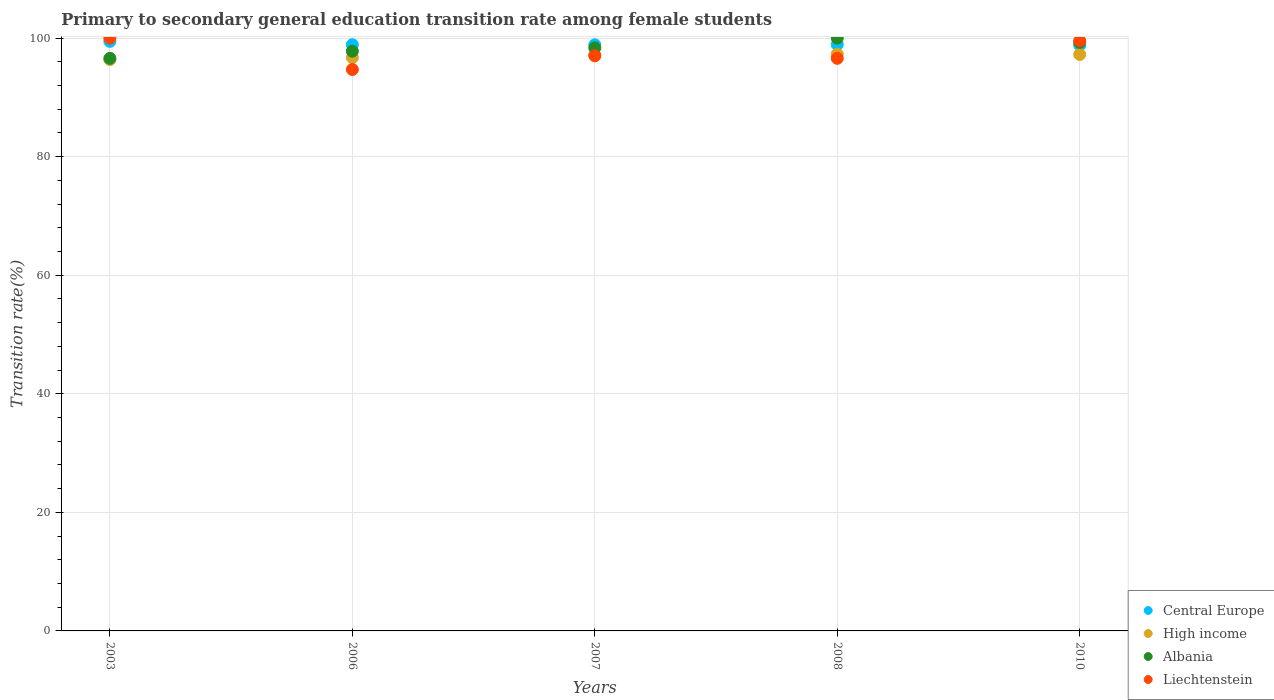Across all years, what is the maximum transition rate in Central Europe?
Your response must be concise. 99.45. Across all years, what is the minimum transition rate in High income?
Provide a succinct answer. 96.4. What is the total transition rate in Central Europe in the graph?
Offer a very short reply. 494.95. What is the difference between the transition rate in Liechtenstein in 2008 and that in 2010?
Give a very brief answer. -2.96. What is the difference between the transition rate in Albania in 2008 and the transition rate in Central Europe in 2007?
Offer a very short reply. 1.12. What is the average transition rate in High income per year?
Provide a succinct answer. 96.97. In the year 2007, what is the difference between the transition rate in Albania and transition rate in High income?
Offer a terse response. 1.19. In how many years, is the transition rate in Liechtenstein greater than 60 %?
Your response must be concise. 5. What is the ratio of the transition rate in Albania in 2006 to that in 2008?
Give a very brief answer. 0.98. Is the transition rate in Central Europe in 2007 less than that in 2008?
Provide a succinct answer. Yes. Is the difference between the transition rate in Albania in 2006 and 2007 greater than the difference between the transition rate in High income in 2006 and 2007?
Your answer should be compact. No. What is the difference between the highest and the second highest transition rate in Central Europe?
Keep it short and to the point. 0.53. What is the difference between the highest and the lowest transition rate in Central Europe?
Offer a terse response. 0.65. Is it the case that in every year, the sum of the transition rate in Central Europe and transition rate in Liechtenstein  is greater than the sum of transition rate in Albania and transition rate in High income?
Keep it short and to the point. No. Is it the case that in every year, the sum of the transition rate in Albania and transition rate in Liechtenstein  is greater than the transition rate in High income?
Your response must be concise. Yes. Does the transition rate in Central Europe monotonically increase over the years?
Offer a terse response. No. Is the transition rate in Liechtenstein strictly less than the transition rate in High income over the years?
Your answer should be very brief. No. What is the title of the graph?
Your answer should be very brief. Primary to secondary general education transition rate among female students. Does "Somalia" appear as one of the legend labels in the graph?
Your response must be concise. No. What is the label or title of the Y-axis?
Provide a succinct answer. Transition rate(%). What is the Transition rate(%) of Central Europe in 2003?
Give a very brief answer. 99.45. What is the Transition rate(%) of High income in 2003?
Your answer should be very brief. 96.4. What is the Transition rate(%) of Albania in 2003?
Your answer should be compact. 96.59. What is the Transition rate(%) in Central Europe in 2006?
Provide a short and direct response. 98.9. What is the Transition rate(%) in High income in 2006?
Offer a terse response. 96.72. What is the Transition rate(%) in Albania in 2006?
Your response must be concise. 97.79. What is the Transition rate(%) in Liechtenstein in 2006?
Your answer should be compact. 94.71. What is the Transition rate(%) of Central Europe in 2007?
Your answer should be very brief. 98.88. What is the Transition rate(%) in High income in 2007?
Your answer should be compact. 97.17. What is the Transition rate(%) of Albania in 2007?
Your response must be concise. 98.36. What is the Transition rate(%) in Liechtenstein in 2007?
Ensure brevity in your answer.  97.02. What is the Transition rate(%) of Central Europe in 2008?
Keep it short and to the point. 98.92. What is the Transition rate(%) of High income in 2008?
Keep it short and to the point. 97.3. What is the Transition rate(%) in Albania in 2008?
Ensure brevity in your answer.  100. What is the Transition rate(%) in Liechtenstein in 2008?
Your answer should be very brief. 96.6. What is the Transition rate(%) in Central Europe in 2010?
Offer a very short reply. 98.81. What is the Transition rate(%) in High income in 2010?
Keep it short and to the point. 97.24. What is the Transition rate(%) of Albania in 2010?
Your response must be concise. 99.28. What is the Transition rate(%) of Liechtenstein in 2010?
Offer a terse response. 99.56. Across all years, what is the maximum Transition rate(%) in Central Europe?
Make the answer very short. 99.45. Across all years, what is the maximum Transition rate(%) of High income?
Your answer should be very brief. 97.3. Across all years, what is the minimum Transition rate(%) of Central Europe?
Offer a very short reply. 98.81. Across all years, what is the minimum Transition rate(%) in High income?
Offer a very short reply. 96.4. Across all years, what is the minimum Transition rate(%) of Albania?
Your answer should be very brief. 96.59. Across all years, what is the minimum Transition rate(%) of Liechtenstein?
Your response must be concise. 94.71. What is the total Transition rate(%) in Central Europe in the graph?
Provide a short and direct response. 494.95. What is the total Transition rate(%) in High income in the graph?
Offer a terse response. 484.83. What is the total Transition rate(%) of Albania in the graph?
Ensure brevity in your answer.  492.02. What is the total Transition rate(%) of Liechtenstein in the graph?
Give a very brief answer. 487.88. What is the difference between the Transition rate(%) of Central Europe in 2003 and that in 2006?
Give a very brief answer. 0.56. What is the difference between the Transition rate(%) of High income in 2003 and that in 2006?
Make the answer very short. -0.32. What is the difference between the Transition rate(%) in Albania in 2003 and that in 2006?
Give a very brief answer. -1.2. What is the difference between the Transition rate(%) in Liechtenstein in 2003 and that in 2006?
Offer a terse response. 5.29. What is the difference between the Transition rate(%) in Central Europe in 2003 and that in 2007?
Keep it short and to the point. 0.57. What is the difference between the Transition rate(%) in High income in 2003 and that in 2007?
Provide a succinct answer. -0.77. What is the difference between the Transition rate(%) in Albania in 2003 and that in 2007?
Your answer should be very brief. -1.77. What is the difference between the Transition rate(%) of Liechtenstein in 2003 and that in 2007?
Provide a succinct answer. 2.98. What is the difference between the Transition rate(%) in Central Europe in 2003 and that in 2008?
Offer a terse response. 0.53. What is the difference between the Transition rate(%) of High income in 2003 and that in 2008?
Your response must be concise. -0.91. What is the difference between the Transition rate(%) in Albania in 2003 and that in 2008?
Your response must be concise. -3.41. What is the difference between the Transition rate(%) in Liechtenstein in 2003 and that in 2008?
Offer a very short reply. 3.4. What is the difference between the Transition rate(%) of Central Europe in 2003 and that in 2010?
Offer a very short reply. 0.65. What is the difference between the Transition rate(%) of High income in 2003 and that in 2010?
Your response must be concise. -0.85. What is the difference between the Transition rate(%) of Albania in 2003 and that in 2010?
Your answer should be very brief. -2.68. What is the difference between the Transition rate(%) in Liechtenstein in 2003 and that in 2010?
Your answer should be very brief. 0.44. What is the difference between the Transition rate(%) in Central Europe in 2006 and that in 2007?
Provide a succinct answer. 0.02. What is the difference between the Transition rate(%) in High income in 2006 and that in 2007?
Your answer should be compact. -0.45. What is the difference between the Transition rate(%) in Albania in 2006 and that in 2007?
Ensure brevity in your answer.  -0.57. What is the difference between the Transition rate(%) in Liechtenstein in 2006 and that in 2007?
Ensure brevity in your answer.  -2.31. What is the difference between the Transition rate(%) of Central Europe in 2006 and that in 2008?
Provide a succinct answer. -0.02. What is the difference between the Transition rate(%) in High income in 2006 and that in 2008?
Give a very brief answer. -0.58. What is the difference between the Transition rate(%) of Albania in 2006 and that in 2008?
Keep it short and to the point. -2.21. What is the difference between the Transition rate(%) of Liechtenstein in 2006 and that in 2008?
Make the answer very short. -1.88. What is the difference between the Transition rate(%) of Central Europe in 2006 and that in 2010?
Offer a terse response. 0.09. What is the difference between the Transition rate(%) of High income in 2006 and that in 2010?
Your answer should be compact. -0.52. What is the difference between the Transition rate(%) in Albania in 2006 and that in 2010?
Offer a terse response. -1.49. What is the difference between the Transition rate(%) in Liechtenstein in 2006 and that in 2010?
Ensure brevity in your answer.  -4.84. What is the difference between the Transition rate(%) in Central Europe in 2007 and that in 2008?
Keep it short and to the point. -0.04. What is the difference between the Transition rate(%) in High income in 2007 and that in 2008?
Give a very brief answer. -0.14. What is the difference between the Transition rate(%) in Albania in 2007 and that in 2008?
Offer a very short reply. -1.64. What is the difference between the Transition rate(%) in Liechtenstein in 2007 and that in 2008?
Provide a short and direct response. 0.42. What is the difference between the Transition rate(%) of Central Europe in 2007 and that in 2010?
Provide a short and direct response. 0.07. What is the difference between the Transition rate(%) in High income in 2007 and that in 2010?
Provide a short and direct response. -0.07. What is the difference between the Transition rate(%) in Albania in 2007 and that in 2010?
Keep it short and to the point. -0.92. What is the difference between the Transition rate(%) of Liechtenstein in 2007 and that in 2010?
Your response must be concise. -2.54. What is the difference between the Transition rate(%) of Central Europe in 2008 and that in 2010?
Make the answer very short. 0.11. What is the difference between the Transition rate(%) in High income in 2008 and that in 2010?
Give a very brief answer. 0.06. What is the difference between the Transition rate(%) in Albania in 2008 and that in 2010?
Offer a terse response. 0.72. What is the difference between the Transition rate(%) of Liechtenstein in 2008 and that in 2010?
Your answer should be compact. -2.96. What is the difference between the Transition rate(%) in Central Europe in 2003 and the Transition rate(%) in High income in 2006?
Make the answer very short. 2.73. What is the difference between the Transition rate(%) of Central Europe in 2003 and the Transition rate(%) of Albania in 2006?
Your response must be concise. 1.66. What is the difference between the Transition rate(%) in Central Europe in 2003 and the Transition rate(%) in Liechtenstein in 2006?
Your answer should be very brief. 4.74. What is the difference between the Transition rate(%) of High income in 2003 and the Transition rate(%) of Albania in 2006?
Ensure brevity in your answer.  -1.4. What is the difference between the Transition rate(%) in High income in 2003 and the Transition rate(%) in Liechtenstein in 2006?
Your response must be concise. 1.68. What is the difference between the Transition rate(%) in Albania in 2003 and the Transition rate(%) in Liechtenstein in 2006?
Provide a short and direct response. 1.88. What is the difference between the Transition rate(%) of Central Europe in 2003 and the Transition rate(%) of High income in 2007?
Offer a terse response. 2.28. What is the difference between the Transition rate(%) of Central Europe in 2003 and the Transition rate(%) of Albania in 2007?
Give a very brief answer. 1.09. What is the difference between the Transition rate(%) of Central Europe in 2003 and the Transition rate(%) of Liechtenstein in 2007?
Provide a succinct answer. 2.44. What is the difference between the Transition rate(%) of High income in 2003 and the Transition rate(%) of Albania in 2007?
Ensure brevity in your answer.  -1.97. What is the difference between the Transition rate(%) of High income in 2003 and the Transition rate(%) of Liechtenstein in 2007?
Your answer should be very brief. -0.62. What is the difference between the Transition rate(%) in Albania in 2003 and the Transition rate(%) in Liechtenstein in 2007?
Provide a succinct answer. -0.42. What is the difference between the Transition rate(%) in Central Europe in 2003 and the Transition rate(%) in High income in 2008?
Your response must be concise. 2.15. What is the difference between the Transition rate(%) of Central Europe in 2003 and the Transition rate(%) of Albania in 2008?
Offer a terse response. -0.55. What is the difference between the Transition rate(%) of Central Europe in 2003 and the Transition rate(%) of Liechtenstein in 2008?
Keep it short and to the point. 2.86. What is the difference between the Transition rate(%) in High income in 2003 and the Transition rate(%) in Albania in 2008?
Your answer should be compact. -3.6. What is the difference between the Transition rate(%) in High income in 2003 and the Transition rate(%) in Liechtenstein in 2008?
Give a very brief answer. -0.2. What is the difference between the Transition rate(%) of Albania in 2003 and the Transition rate(%) of Liechtenstein in 2008?
Give a very brief answer. -0. What is the difference between the Transition rate(%) of Central Europe in 2003 and the Transition rate(%) of High income in 2010?
Provide a succinct answer. 2.21. What is the difference between the Transition rate(%) in Central Europe in 2003 and the Transition rate(%) in Albania in 2010?
Ensure brevity in your answer.  0.18. What is the difference between the Transition rate(%) of Central Europe in 2003 and the Transition rate(%) of Liechtenstein in 2010?
Offer a terse response. -0.1. What is the difference between the Transition rate(%) in High income in 2003 and the Transition rate(%) in Albania in 2010?
Provide a succinct answer. -2.88. What is the difference between the Transition rate(%) of High income in 2003 and the Transition rate(%) of Liechtenstein in 2010?
Keep it short and to the point. -3.16. What is the difference between the Transition rate(%) in Albania in 2003 and the Transition rate(%) in Liechtenstein in 2010?
Offer a very short reply. -2.96. What is the difference between the Transition rate(%) of Central Europe in 2006 and the Transition rate(%) of High income in 2007?
Your response must be concise. 1.73. What is the difference between the Transition rate(%) of Central Europe in 2006 and the Transition rate(%) of Albania in 2007?
Provide a short and direct response. 0.54. What is the difference between the Transition rate(%) of Central Europe in 2006 and the Transition rate(%) of Liechtenstein in 2007?
Ensure brevity in your answer.  1.88. What is the difference between the Transition rate(%) in High income in 2006 and the Transition rate(%) in Albania in 2007?
Offer a terse response. -1.64. What is the difference between the Transition rate(%) in High income in 2006 and the Transition rate(%) in Liechtenstein in 2007?
Provide a succinct answer. -0.3. What is the difference between the Transition rate(%) of Albania in 2006 and the Transition rate(%) of Liechtenstein in 2007?
Your answer should be compact. 0.77. What is the difference between the Transition rate(%) of Central Europe in 2006 and the Transition rate(%) of High income in 2008?
Offer a very short reply. 1.59. What is the difference between the Transition rate(%) in Central Europe in 2006 and the Transition rate(%) in Albania in 2008?
Your answer should be compact. -1.1. What is the difference between the Transition rate(%) in Central Europe in 2006 and the Transition rate(%) in Liechtenstein in 2008?
Provide a succinct answer. 2.3. What is the difference between the Transition rate(%) in High income in 2006 and the Transition rate(%) in Albania in 2008?
Your response must be concise. -3.28. What is the difference between the Transition rate(%) of High income in 2006 and the Transition rate(%) of Liechtenstein in 2008?
Your answer should be compact. 0.12. What is the difference between the Transition rate(%) of Albania in 2006 and the Transition rate(%) of Liechtenstein in 2008?
Provide a succinct answer. 1.2. What is the difference between the Transition rate(%) in Central Europe in 2006 and the Transition rate(%) in High income in 2010?
Your answer should be compact. 1.65. What is the difference between the Transition rate(%) of Central Europe in 2006 and the Transition rate(%) of Albania in 2010?
Keep it short and to the point. -0.38. What is the difference between the Transition rate(%) of Central Europe in 2006 and the Transition rate(%) of Liechtenstein in 2010?
Give a very brief answer. -0.66. What is the difference between the Transition rate(%) of High income in 2006 and the Transition rate(%) of Albania in 2010?
Offer a terse response. -2.56. What is the difference between the Transition rate(%) of High income in 2006 and the Transition rate(%) of Liechtenstein in 2010?
Your answer should be compact. -2.84. What is the difference between the Transition rate(%) in Albania in 2006 and the Transition rate(%) in Liechtenstein in 2010?
Provide a succinct answer. -1.76. What is the difference between the Transition rate(%) in Central Europe in 2007 and the Transition rate(%) in High income in 2008?
Ensure brevity in your answer.  1.58. What is the difference between the Transition rate(%) of Central Europe in 2007 and the Transition rate(%) of Albania in 2008?
Offer a terse response. -1.12. What is the difference between the Transition rate(%) of Central Europe in 2007 and the Transition rate(%) of Liechtenstein in 2008?
Your response must be concise. 2.28. What is the difference between the Transition rate(%) in High income in 2007 and the Transition rate(%) in Albania in 2008?
Make the answer very short. -2.83. What is the difference between the Transition rate(%) of High income in 2007 and the Transition rate(%) of Liechtenstein in 2008?
Your answer should be very brief. 0.57. What is the difference between the Transition rate(%) in Albania in 2007 and the Transition rate(%) in Liechtenstein in 2008?
Provide a short and direct response. 1.77. What is the difference between the Transition rate(%) of Central Europe in 2007 and the Transition rate(%) of High income in 2010?
Your response must be concise. 1.64. What is the difference between the Transition rate(%) of Central Europe in 2007 and the Transition rate(%) of Albania in 2010?
Provide a succinct answer. -0.4. What is the difference between the Transition rate(%) of Central Europe in 2007 and the Transition rate(%) of Liechtenstein in 2010?
Provide a short and direct response. -0.68. What is the difference between the Transition rate(%) of High income in 2007 and the Transition rate(%) of Albania in 2010?
Your response must be concise. -2.11. What is the difference between the Transition rate(%) of High income in 2007 and the Transition rate(%) of Liechtenstein in 2010?
Ensure brevity in your answer.  -2.39. What is the difference between the Transition rate(%) in Albania in 2007 and the Transition rate(%) in Liechtenstein in 2010?
Make the answer very short. -1.19. What is the difference between the Transition rate(%) of Central Europe in 2008 and the Transition rate(%) of High income in 2010?
Your response must be concise. 1.68. What is the difference between the Transition rate(%) in Central Europe in 2008 and the Transition rate(%) in Albania in 2010?
Provide a succinct answer. -0.36. What is the difference between the Transition rate(%) in Central Europe in 2008 and the Transition rate(%) in Liechtenstein in 2010?
Keep it short and to the point. -0.64. What is the difference between the Transition rate(%) in High income in 2008 and the Transition rate(%) in Albania in 2010?
Your answer should be compact. -1.97. What is the difference between the Transition rate(%) of High income in 2008 and the Transition rate(%) of Liechtenstein in 2010?
Provide a succinct answer. -2.25. What is the difference between the Transition rate(%) in Albania in 2008 and the Transition rate(%) in Liechtenstein in 2010?
Offer a very short reply. 0.44. What is the average Transition rate(%) of Central Europe per year?
Provide a succinct answer. 98.99. What is the average Transition rate(%) in High income per year?
Provide a succinct answer. 96.97. What is the average Transition rate(%) of Albania per year?
Offer a terse response. 98.4. What is the average Transition rate(%) in Liechtenstein per year?
Your answer should be very brief. 97.58. In the year 2003, what is the difference between the Transition rate(%) in Central Europe and Transition rate(%) in High income?
Your answer should be very brief. 3.06. In the year 2003, what is the difference between the Transition rate(%) in Central Europe and Transition rate(%) in Albania?
Your response must be concise. 2.86. In the year 2003, what is the difference between the Transition rate(%) in Central Europe and Transition rate(%) in Liechtenstein?
Your response must be concise. -0.55. In the year 2003, what is the difference between the Transition rate(%) in High income and Transition rate(%) in Albania?
Make the answer very short. -0.2. In the year 2003, what is the difference between the Transition rate(%) in High income and Transition rate(%) in Liechtenstein?
Offer a very short reply. -3.6. In the year 2003, what is the difference between the Transition rate(%) of Albania and Transition rate(%) of Liechtenstein?
Offer a terse response. -3.41. In the year 2006, what is the difference between the Transition rate(%) in Central Europe and Transition rate(%) in High income?
Keep it short and to the point. 2.18. In the year 2006, what is the difference between the Transition rate(%) of Central Europe and Transition rate(%) of Albania?
Your answer should be very brief. 1.1. In the year 2006, what is the difference between the Transition rate(%) in Central Europe and Transition rate(%) in Liechtenstein?
Your answer should be very brief. 4.19. In the year 2006, what is the difference between the Transition rate(%) in High income and Transition rate(%) in Albania?
Offer a very short reply. -1.07. In the year 2006, what is the difference between the Transition rate(%) of High income and Transition rate(%) of Liechtenstein?
Offer a terse response. 2.01. In the year 2006, what is the difference between the Transition rate(%) in Albania and Transition rate(%) in Liechtenstein?
Your answer should be very brief. 3.08. In the year 2007, what is the difference between the Transition rate(%) of Central Europe and Transition rate(%) of High income?
Provide a succinct answer. 1.71. In the year 2007, what is the difference between the Transition rate(%) in Central Europe and Transition rate(%) in Albania?
Provide a short and direct response. 0.52. In the year 2007, what is the difference between the Transition rate(%) of Central Europe and Transition rate(%) of Liechtenstein?
Your answer should be compact. 1.86. In the year 2007, what is the difference between the Transition rate(%) in High income and Transition rate(%) in Albania?
Your answer should be compact. -1.19. In the year 2007, what is the difference between the Transition rate(%) of High income and Transition rate(%) of Liechtenstein?
Make the answer very short. 0.15. In the year 2007, what is the difference between the Transition rate(%) in Albania and Transition rate(%) in Liechtenstein?
Your answer should be very brief. 1.34. In the year 2008, what is the difference between the Transition rate(%) in Central Europe and Transition rate(%) in High income?
Your answer should be very brief. 1.61. In the year 2008, what is the difference between the Transition rate(%) of Central Europe and Transition rate(%) of Albania?
Your answer should be very brief. -1.08. In the year 2008, what is the difference between the Transition rate(%) in Central Europe and Transition rate(%) in Liechtenstein?
Your answer should be very brief. 2.32. In the year 2008, what is the difference between the Transition rate(%) of High income and Transition rate(%) of Albania?
Provide a succinct answer. -2.7. In the year 2008, what is the difference between the Transition rate(%) of High income and Transition rate(%) of Liechtenstein?
Your answer should be compact. 0.71. In the year 2008, what is the difference between the Transition rate(%) in Albania and Transition rate(%) in Liechtenstein?
Provide a short and direct response. 3.4. In the year 2010, what is the difference between the Transition rate(%) of Central Europe and Transition rate(%) of High income?
Make the answer very short. 1.56. In the year 2010, what is the difference between the Transition rate(%) in Central Europe and Transition rate(%) in Albania?
Your answer should be very brief. -0.47. In the year 2010, what is the difference between the Transition rate(%) in Central Europe and Transition rate(%) in Liechtenstein?
Provide a succinct answer. -0.75. In the year 2010, what is the difference between the Transition rate(%) in High income and Transition rate(%) in Albania?
Provide a short and direct response. -2.03. In the year 2010, what is the difference between the Transition rate(%) of High income and Transition rate(%) of Liechtenstein?
Provide a short and direct response. -2.31. In the year 2010, what is the difference between the Transition rate(%) in Albania and Transition rate(%) in Liechtenstein?
Provide a succinct answer. -0.28. What is the ratio of the Transition rate(%) of Central Europe in 2003 to that in 2006?
Keep it short and to the point. 1.01. What is the ratio of the Transition rate(%) in High income in 2003 to that in 2006?
Ensure brevity in your answer.  1. What is the ratio of the Transition rate(%) of Liechtenstein in 2003 to that in 2006?
Your response must be concise. 1.06. What is the ratio of the Transition rate(%) of High income in 2003 to that in 2007?
Your response must be concise. 0.99. What is the ratio of the Transition rate(%) in Liechtenstein in 2003 to that in 2007?
Your answer should be compact. 1.03. What is the ratio of the Transition rate(%) in Central Europe in 2003 to that in 2008?
Your response must be concise. 1.01. What is the ratio of the Transition rate(%) of High income in 2003 to that in 2008?
Provide a short and direct response. 0.99. What is the ratio of the Transition rate(%) of Albania in 2003 to that in 2008?
Make the answer very short. 0.97. What is the ratio of the Transition rate(%) in Liechtenstein in 2003 to that in 2008?
Your answer should be compact. 1.04. What is the ratio of the Transition rate(%) of Central Europe in 2003 to that in 2010?
Provide a succinct answer. 1.01. What is the ratio of the Transition rate(%) of High income in 2003 to that in 2010?
Your response must be concise. 0.99. What is the ratio of the Transition rate(%) of Central Europe in 2006 to that in 2007?
Your response must be concise. 1. What is the ratio of the Transition rate(%) of Albania in 2006 to that in 2007?
Make the answer very short. 0.99. What is the ratio of the Transition rate(%) of Liechtenstein in 2006 to that in 2007?
Ensure brevity in your answer.  0.98. What is the ratio of the Transition rate(%) of Central Europe in 2006 to that in 2008?
Your answer should be compact. 1. What is the ratio of the Transition rate(%) of High income in 2006 to that in 2008?
Ensure brevity in your answer.  0.99. What is the ratio of the Transition rate(%) of Albania in 2006 to that in 2008?
Ensure brevity in your answer.  0.98. What is the ratio of the Transition rate(%) in Liechtenstein in 2006 to that in 2008?
Offer a very short reply. 0.98. What is the ratio of the Transition rate(%) in High income in 2006 to that in 2010?
Make the answer very short. 0.99. What is the ratio of the Transition rate(%) of Liechtenstein in 2006 to that in 2010?
Offer a terse response. 0.95. What is the ratio of the Transition rate(%) in High income in 2007 to that in 2008?
Keep it short and to the point. 1. What is the ratio of the Transition rate(%) of Albania in 2007 to that in 2008?
Your response must be concise. 0.98. What is the ratio of the Transition rate(%) of Liechtenstein in 2007 to that in 2008?
Your response must be concise. 1. What is the ratio of the Transition rate(%) of Liechtenstein in 2007 to that in 2010?
Your response must be concise. 0.97. What is the ratio of the Transition rate(%) of Albania in 2008 to that in 2010?
Offer a terse response. 1.01. What is the ratio of the Transition rate(%) in Liechtenstein in 2008 to that in 2010?
Your answer should be very brief. 0.97. What is the difference between the highest and the second highest Transition rate(%) in Central Europe?
Keep it short and to the point. 0.53. What is the difference between the highest and the second highest Transition rate(%) of High income?
Offer a very short reply. 0.06. What is the difference between the highest and the second highest Transition rate(%) in Albania?
Your answer should be very brief. 0.72. What is the difference between the highest and the second highest Transition rate(%) of Liechtenstein?
Keep it short and to the point. 0.44. What is the difference between the highest and the lowest Transition rate(%) in Central Europe?
Make the answer very short. 0.65. What is the difference between the highest and the lowest Transition rate(%) in High income?
Keep it short and to the point. 0.91. What is the difference between the highest and the lowest Transition rate(%) in Albania?
Keep it short and to the point. 3.41. What is the difference between the highest and the lowest Transition rate(%) of Liechtenstein?
Provide a succinct answer. 5.29. 